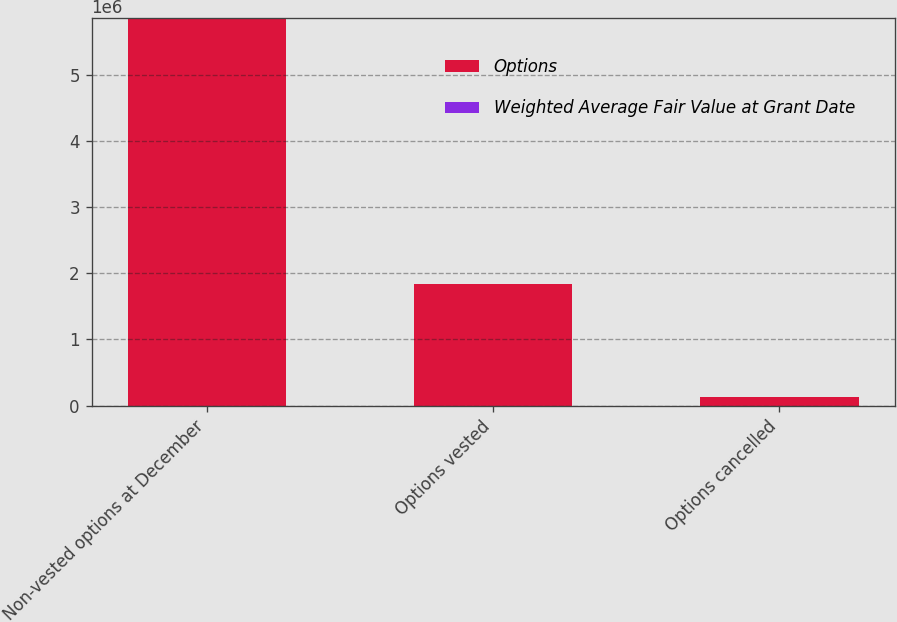Convert chart. <chart><loc_0><loc_0><loc_500><loc_500><stacked_bar_chart><ecel><fcel>Non-vested options at December<fcel>Options vested<fcel>Options cancelled<nl><fcel>Options<fcel>5.85284e+06<fcel>1.84293e+06<fcel>128880<nl><fcel>Weighted Average Fair Value at Grant Date<fcel>11.03<fcel>6.92<fcel>9.37<nl></chart> 